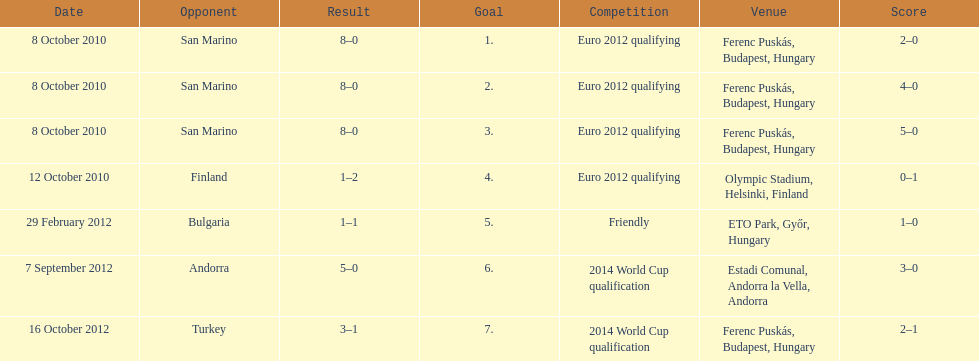Szalai scored just one additional international goal against all other nations combined compared to his score against which single country? San Marino. 